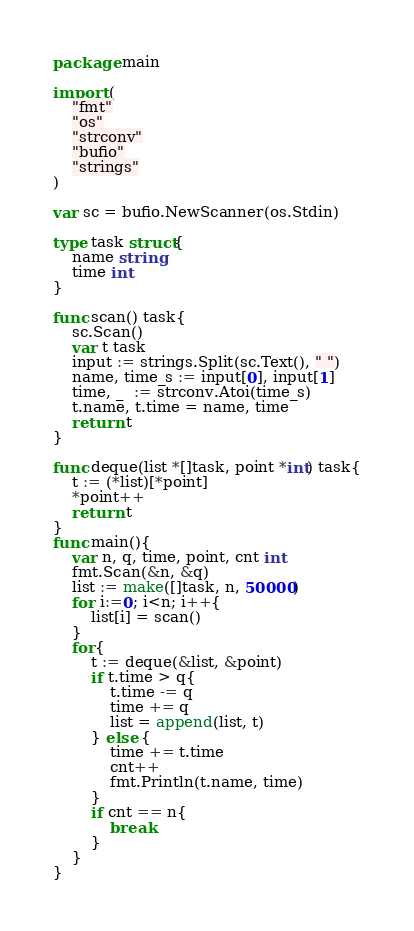<code> <loc_0><loc_0><loc_500><loc_500><_Go_>package main

import (
	"fmt"
	"os"
	"strconv"
	"bufio"
	"strings"
)

var sc = bufio.NewScanner(os.Stdin)

type task struct{
	name string
	time int 
}

func scan() task{
	sc.Scan()
	var t task
	input := strings.Split(sc.Text(), " ")
	name, time_s := input[0], input[1]
	time, _  := strconv.Atoi(time_s)
	t.name, t.time = name, time
	return t
}

func deque(list *[]task, point *int) task{
	t := (*list)[*point]
	*point++
	return t
}
func main(){
	var n, q, time, point, cnt int
	fmt.Scan(&n, &q)
	list := make([]task, n, 50000)
	for i:=0; i<n; i++{
		list[i] = scan()
	}
	for{
		t := deque(&list, &point)
		if t.time > q{
			t.time -= q
			time += q
			list = append(list, t)
		} else {
			time += t.time
			cnt++
			fmt.Println(t.name, time)
		}
		if cnt == n{
			break
		}
	}
}
</code> 